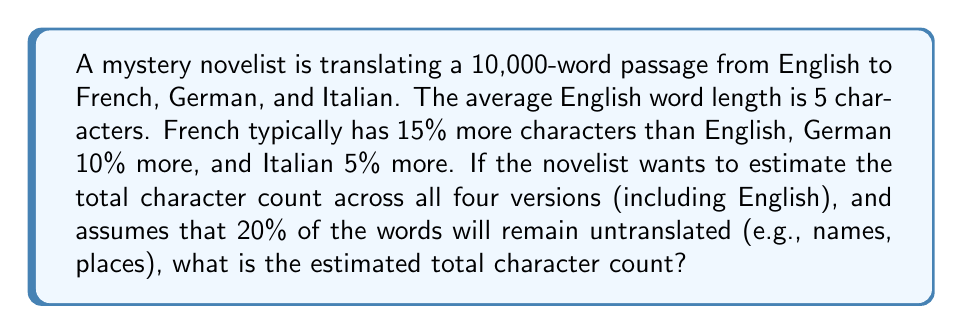Solve this math problem. Let's approach this step-by-step:

1) First, calculate the character count for the English version:
   $10,000 \text{ words} \times 5 \text{ characters/word} = 50,000 \text{ characters}$

2) Calculate the number of words that will be translated:
   $80\% \text{ of } 10,000 = 8,000 \text{ words}$

3) Calculate the additional characters for each language:
   French: $50,000 \times 15\% = 7,500 \text{ additional characters}$
   German: $50,000 \times 10\% = 5,000 \text{ additional characters}$
   Italian: $50,000 \times 5\% = 2,500 \text{ additional characters}$

4) Calculate the total additional characters:
   $7,500 + 5,000 + 2,500 = 15,000 \text{ additional characters}$

5) However, these additional characters only apply to the translated words (80%):
   $15,000 \times 80\% = 12,000 \text{ actual additional characters}$

6) Calculate the total character count across all versions:
   $50,000 \text{ (English)} + 50,000 \text{ (French)} + 50,000 \text{ (German)} + 50,000 \text{ (Italian)} + 12,000 \text{ (additional from translations)} = 212,000 \text{ characters}$
Answer: 212,000 characters 